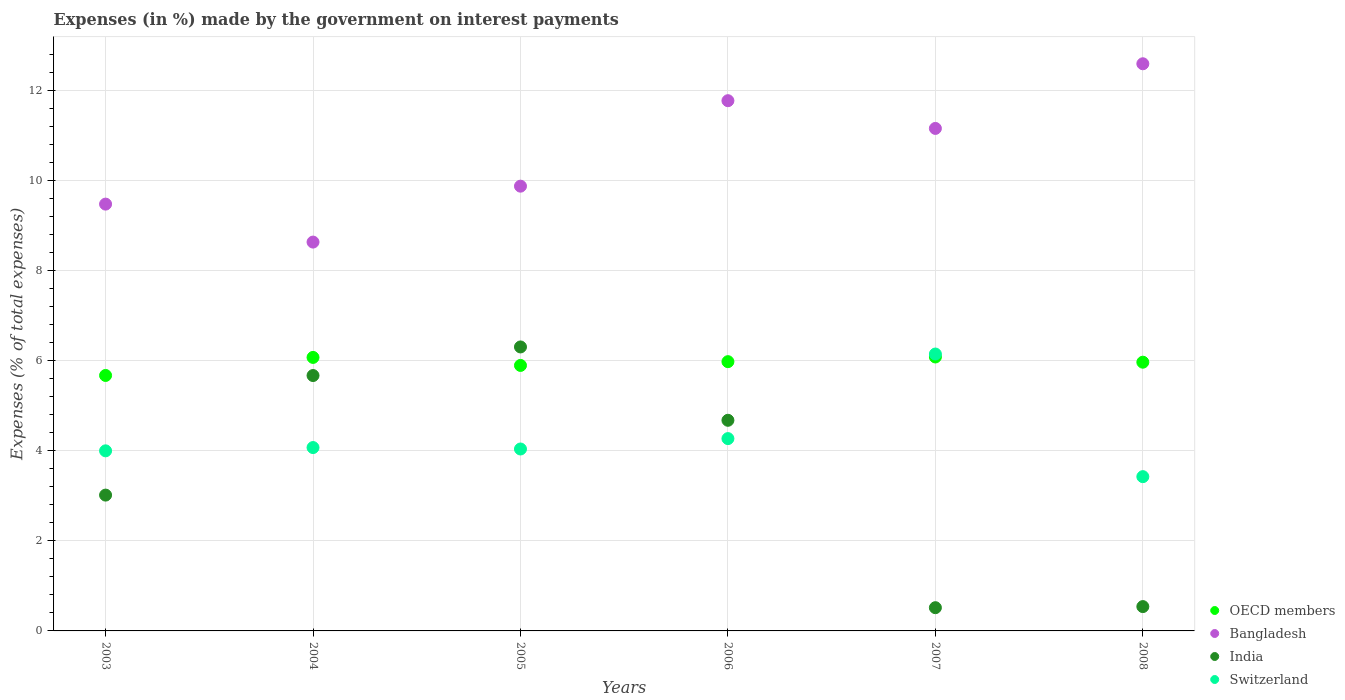How many different coloured dotlines are there?
Make the answer very short. 4. Is the number of dotlines equal to the number of legend labels?
Your answer should be very brief. Yes. What is the percentage of expenses made by the government on interest payments in Bangladesh in 2004?
Ensure brevity in your answer.  8.63. Across all years, what is the maximum percentage of expenses made by the government on interest payments in OECD members?
Give a very brief answer. 6.08. Across all years, what is the minimum percentage of expenses made by the government on interest payments in Bangladesh?
Your response must be concise. 8.63. In which year was the percentage of expenses made by the government on interest payments in OECD members maximum?
Keep it short and to the point. 2007. What is the total percentage of expenses made by the government on interest payments in OECD members in the graph?
Ensure brevity in your answer.  35.66. What is the difference between the percentage of expenses made by the government on interest payments in Bangladesh in 2005 and that in 2007?
Provide a short and direct response. -1.28. What is the difference between the percentage of expenses made by the government on interest payments in India in 2003 and the percentage of expenses made by the government on interest payments in Switzerland in 2008?
Provide a short and direct response. -0.41. What is the average percentage of expenses made by the government on interest payments in Bangladesh per year?
Provide a short and direct response. 10.58. In the year 2006, what is the difference between the percentage of expenses made by the government on interest payments in Switzerland and percentage of expenses made by the government on interest payments in Bangladesh?
Provide a succinct answer. -7.5. What is the ratio of the percentage of expenses made by the government on interest payments in India in 2003 to that in 2005?
Your answer should be compact. 0.48. Is the percentage of expenses made by the government on interest payments in Bangladesh in 2004 less than that in 2006?
Provide a short and direct response. Yes. What is the difference between the highest and the second highest percentage of expenses made by the government on interest payments in OECD members?
Offer a very short reply. 0.01. What is the difference between the highest and the lowest percentage of expenses made by the government on interest payments in Switzerland?
Your answer should be very brief. 2.72. In how many years, is the percentage of expenses made by the government on interest payments in Bangladesh greater than the average percentage of expenses made by the government on interest payments in Bangladesh taken over all years?
Your answer should be very brief. 3. Is the sum of the percentage of expenses made by the government on interest payments in Switzerland in 2007 and 2008 greater than the maximum percentage of expenses made by the government on interest payments in India across all years?
Offer a very short reply. Yes. Is the percentage of expenses made by the government on interest payments in Switzerland strictly greater than the percentage of expenses made by the government on interest payments in India over the years?
Make the answer very short. No. How many dotlines are there?
Your answer should be very brief. 4. How many years are there in the graph?
Provide a succinct answer. 6. What is the difference between two consecutive major ticks on the Y-axis?
Keep it short and to the point. 2. Are the values on the major ticks of Y-axis written in scientific E-notation?
Ensure brevity in your answer.  No. Does the graph contain grids?
Ensure brevity in your answer.  Yes. Where does the legend appear in the graph?
Ensure brevity in your answer.  Bottom right. How many legend labels are there?
Offer a terse response. 4. How are the legend labels stacked?
Give a very brief answer. Vertical. What is the title of the graph?
Give a very brief answer. Expenses (in %) made by the government on interest payments. What is the label or title of the Y-axis?
Give a very brief answer. Expenses (% of total expenses). What is the Expenses (% of total expenses) of OECD members in 2003?
Offer a terse response. 5.67. What is the Expenses (% of total expenses) of Bangladesh in 2003?
Your answer should be very brief. 9.48. What is the Expenses (% of total expenses) of India in 2003?
Make the answer very short. 3.02. What is the Expenses (% of total expenses) of Switzerland in 2003?
Give a very brief answer. 4. What is the Expenses (% of total expenses) of OECD members in 2004?
Provide a short and direct response. 6.07. What is the Expenses (% of total expenses) of Bangladesh in 2004?
Your answer should be very brief. 8.63. What is the Expenses (% of total expenses) in India in 2004?
Your response must be concise. 5.67. What is the Expenses (% of total expenses) of Switzerland in 2004?
Make the answer very short. 4.07. What is the Expenses (% of total expenses) in OECD members in 2005?
Make the answer very short. 5.89. What is the Expenses (% of total expenses) of Bangladesh in 2005?
Keep it short and to the point. 9.87. What is the Expenses (% of total expenses) in India in 2005?
Offer a terse response. 6.3. What is the Expenses (% of total expenses) of Switzerland in 2005?
Give a very brief answer. 4.04. What is the Expenses (% of total expenses) of OECD members in 2006?
Provide a succinct answer. 5.98. What is the Expenses (% of total expenses) in Bangladesh in 2006?
Provide a short and direct response. 11.77. What is the Expenses (% of total expenses) of India in 2006?
Provide a succinct answer. 4.68. What is the Expenses (% of total expenses) of Switzerland in 2006?
Keep it short and to the point. 4.27. What is the Expenses (% of total expenses) of OECD members in 2007?
Make the answer very short. 6.08. What is the Expenses (% of total expenses) in Bangladesh in 2007?
Give a very brief answer. 11.16. What is the Expenses (% of total expenses) in India in 2007?
Offer a very short reply. 0.52. What is the Expenses (% of total expenses) in Switzerland in 2007?
Give a very brief answer. 6.15. What is the Expenses (% of total expenses) in OECD members in 2008?
Keep it short and to the point. 5.97. What is the Expenses (% of total expenses) in Bangladesh in 2008?
Provide a succinct answer. 12.59. What is the Expenses (% of total expenses) in India in 2008?
Your answer should be compact. 0.54. What is the Expenses (% of total expenses) in Switzerland in 2008?
Provide a short and direct response. 3.42. Across all years, what is the maximum Expenses (% of total expenses) of OECD members?
Provide a succinct answer. 6.08. Across all years, what is the maximum Expenses (% of total expenses) in Bangladesh?
Make the answer very short. 12.59. Across all years, what is the maximum Expenses (% of total expenses) in India?
Your answer should be very brief. 6.3. Across all years, what is the maximum Expenses (% of total expenses) of Switzerland?
Your answer should be compact. 6.15. Across all years, what is the minimum Expenses (% of total expenses) of OECD members?
Offer a terse response. 5.67. Across all years, what is the minimum Expenses (% of total expenses) in Bangladesh?
Your answer should be very brief. 8.63. Across all years, what is the minimum Expenses (% of total expenses) in India?
Make the answer very short. 0.52. Across all years, what is the minimum Expenses (% of total expenses) of Switzerland?
Your answer should be compact. 3.42. What is the total Expenses (% of total expenses) in OECD members in the graph?
Make the answer very short. 35.66. What is the total Expenses (% of total expenses) in Bangladesh in the graph?
Give a very brief answer. 63.5. What is the total Expenses (% of total expenses) of India in the graph?
Provide a short and direct response. 20.72. What is the total Expenses (% of total expenses) in Switzerland in the graph?
Give a very brief answer. 25.95. What is the difference between the Expenses (% of total expenses) of OECD members in 2003 and that in 2004?
Your answer should be very brief. -0.4. What is the difference between the Expenses (% of total expenses) in Bangladesh in 2003 and that in 2004?
Provide a succinct answer. 0.84. What is the difference between the Expenses (% of total expenses) of India in 2003 and that in 2004?
Provide a succinct answer. -2.65. What is the difference between the Expenses (% of total expenses) of Switzerland in 2003 and that in 2004?
Offer a terse response. -0.07. What is the difference between the Expenses (% of total expenses) in OECD members in 2003 and that in 2005?
Give a very brief answer. -0.22. What is the difference between the Expenses (% of total expenses) in Bangladesh in 2003 and that in 2005?
Ensure brevity in your answer.  -0.4. What is the difference between the Expenses (% of total expenses) in India in 2003 and that in 2005?
Provide a succinct answer. -3.29. What is the difference between the Expenses (% of total expenses) in Switzerland in 2003 and that in 2005?
Provide a short and direct response. -0.04. What is the difference between the Expenses (% of total expenses) in OECD members in 2003 and that in 2006?
Your response must be concise. -0.31. What is the difference between the Expenses (% of total expenses) of Bangladesh in 2003 and that in 2006?
Your answer should be very brief. -2.3. What is the difference between the Expenses (% of total expenses) of India in 2003 and that in 2006?
Provide a succinct answer. -1.66. What is the difference between the Expenses (% of total expenses) in Switzerland in 2003 and that in 2006?
Your answer should be compact. -0.27. What is the difference between the Expenses (% of total expenses) of OECD members in 2003 and that in 2007?
Provide a succinct answer. -0.41. What is the difference between the Expenses (% of total expenses) in Bangladesh in 2003 and that in 2007?
Ensure brevity in your answer.  -1.68. What is the difference between the Expenses (% of total expenses) of India in 2003 and that in 2007?
Your answer should be very brief. 2.5. What is the difference between the Expenses (% of total expenses) of Switzerland in 2003 and that in 2007?
Offer a terse response. -2.15. What is the difference between the Expenses (% of total expenses) of OECD members in 2003 and that in 2008?
Give a very brief answer. -0.29. What is the difference between the Expenses (% of total expenses) in Bangladesh in 2003 and that in 2008?
Keep it short and to the point. -3.12. What is the difference between the Expenses (% of total expenses) of India in 2003 and that in 2008?
Offer a very short reply. 2.48. What is the difference between the Expenses (% of total expenses) in Switzerland in 2003 and that in 2008?
Provide a short and direct response. 0.57. What is the difference between the Expenses (% of total expenses) in OECD members in 2004 and that in 2005?
Your response must be concise. 0.18. What is the difference between the Expenses (% of total expenses) in Bangladesh in 2004 and that in 2005?
Offer a very short reply. -1.24. What is the difference between the Expenses (% of total expenses) of India in 2004 and that in 2005?
Offer a very short reply. -0.63. What is the difference between the Expenses (% of total expenses) of Switzerland in 2004 and that in 2005?
Give a very brief answer. 0.03. What is the difference between the Expenses (% of total expenses) in OECD members in 2004 and that in 2006?
Keep it short and to the point. 0.09. What is the difference between the Expenses (% of total expenses) in Bangladesh in 2004 and that in 2006?
Keep it short and to the point. -3.14. What is the difference between the Expenses (% of total expenses) of India in 2004 and that in 2006?
Offer a very short reply. 0.99. What is the difference between the Expenses (% of total expenses) of Switzerland in 2004 and that in 2006?
Offer a very short reply. -0.2. What is the difference between the Expenses (% of total expenses) in OECD members in 2004 and that in 2007?
Your answer should be compact. -0.01. What is the difference between the Expenses (% of total expenses) in Bangladesh in 2004 and that in 2007?
Make the answer very short. -2.52. What is the difference between the Expenses (% of total expenses) in India in 2004 and that in 2007?
Ensure brevity in your answer.  5.15. What is the difference between the Expenses (% of total expenses) in Switzerland in 2004 and that in 2007?
Keep it short and to the point. -2.08. What is the difference between the Expenses (% of total expenses) in OECD members in 2004 and that in 2008?
Offer a terse response. 0.11. What is the difference between the Expenses (% of total expenses) in Bangladesh in 2004 and that in 2008?
Keep it short and to the point. -3.96. What is the difference between the Expenses (% of total expenses) in India in 2004 and that in 2008?
Make the answer very short. 5.13. What is the difference between the Expenses (% of total expenses) in Switzerland in 2004 and that in 2008?
Offer a terse response. 0.65. What is the difference between the Expenses (% of total expenses) of OECD members in 2005 and that in 2006?
Offer a terse response. -0.08. What is the difference between the Expenses (% of total expenses) in Bangladesh in 2005 and that in 2006?
Offer a very short reply. -1.9. What is the difference between the Expenses (% of total expenses) of India in 2005 and that in 2006?
Keep it short and to the point. 1.63. What is the difference between the Expenses (% of total expenses) in Switzerland in 2005 and that in 2006?
Provide a succinct answer. -0.23. What is the difference between the Expenses (% of total expenses) of OECD members in 2005 and that in 2007?
Your answer should be very brief. -0.19. What is the difference between the Expenses (% of total expenses) of Bangladesh in 2005 and that in 2007?
Give a very brief answer. -1.28. What is the difference between the Expenses (% of total expenses) of India in 2005 and that in 2007?
Your response must be concise. 5.79. What is the difference between the Expenses (% of total expenses) of Switzerland in 2005 and that in 2007?
Your answer should be very brief. -2.11. What is the difference between the Expenses (% of total expenses) in OECD members in 2005 and that in 2008?
Your answer should be very brief. -0.07. What is the difference between the Expenses (% of total expenses) in Bangladesh in 2005 and that in 2008?
Your answer should be very brief. -2.72. What is the difference between the Expenses (% of total expenses) in India in 2005 and that in 2008?
Make the answer very short. 5.76. What is the difference between the Expenses (% of total expenses) of Switzerland in 2005 and that in 2008?
Give a very brief answer. 0.61. What is the difference between the Expenses (% of total expenses) in OECD members in 2006 and that in 2007?
Provide a short and direct response. -0.1. What is the difference between the Expenses (% of total expenses) in Bangladesh in 2006 and that in 2007?
Provide a short and direct response. 0.62. What is the difference between the Expenses (% of total expenses) in India in 2006 and that in 2007?
Your response must be concise. 4.16. What is the difference between the Expenses (% of total expenses) of Switzerland in 2006 and that in 2007?
Make the answer very short. -1.88. What is the difference between the Expenses (% of total expenses) in OECD members in 2006 and that in 2008?
Your answer should be compact. 0.01. What is the difference between the Expenses (% of total expenses) of Bangladesh in 2006 and that in 2008?
Offer a very short reply. -0.82. What is the difference between the Expenses (% of total expenses) in India in 2006 and that in 2008?
Offer a terse response. 4.14. What is the difference between the Expenses (% of total expenses) in Switzerland in 2006 and that in 2008?
Offer a terse response. 0.84. What is the difference between the Expenses (% of total expenses) of OECD members in 2007 and that in 2008?
Provide a succinct answer. 0.12. What is the difference between the Expenses (% of total expenses) of Bangladesh in 2007 and that in 2008?
Your answer should be very brief. -1.44. What is the difference between the Expenses (% of total expenses) in India in 2007 and that in 2008?
Your answer should be compact. -0.02. What is the difference between the Expenses (% of total expenses) in Switzerland in 2007 and that in 2008?
Offer a terse response. 2.72. What is the difference between the Expenses (% of total expenses) of OECD members in 2003 and the Expenses (% of total expenses) of Bangladesh in 2004?
Provide a succinct answer. -2.96. What is the difference between the Expenses (% of total expenses) of OECD members in 2003 and the Expenses (% of total expenses) of India in 2004?
Your response must be concise. 0. What is the difference between the Expenses (% of total expenses) of OECD members in 2003 and the Expenses (% of total expenses) of Switzerland in 2004?
Provide a short and direct response. 1.6. What is the difference between the Expenses (% of total expenses) in Bangladesh in 2003 and the Expenses (% of total expenses) in India in 2004?
Give a very brief answer. 3.81. What is the difference between the Expenses (% of total expenses) of Bangladesh in 2003 and the Expenses (% of total expenses) of Switzerland in 2004?
Your answer should be compact. 5.4. What is the difference between the Expenses (% of total expenses) in India in 2003 and the Expenses (% of total expenses) in Switzerland in 2004?
Provide a succinct answer. -1.06. What is the difference between the Expenses (% of total expenses) of OECD members in 2003 and the Expenses (% of total expenses) of Bangladesh in 2005?
Your response must be concise. -4.2. What is the difference between the Expenses (% of total expenses) of OECD members in 2003 and the Expenses (% of total expenses) of India in 2005?
Make the answer very short. -0.63. What is the difference between the Expenses (% of total expenses) in OECD members in 2003 and the Expenses (% of total expenses) in Switzerland in 2005?
Provide a succinct answer. 1.63. What is the difference between the Expenses (% of total expenses) in Bangladesh in 2003 and the Expenses (% of total expenses) in India in 2005?
Provide a short and direct response. 3.17. What is the difference between the Expenses (% of total expenses) of Bangladesh in 2003 and the Expenses (% of total expenses) of Switzerland in 2005?
Offer a very short reply. 5.44. What is the difference between the Expenses (% of total expenses) in India in 2003 and the Expenses (% of total expenses) in Switzerland in 2005?
Offer a terse response. -1.02. What is the difference between the Expenses (% of total expenses) in OECD members in 2003 and the Expenses (% of total expenses) in Bangladesh in 2006?
Provide a succinct answer. -6.1. What is the difference between the Expenses (% of total expenses) of OECD members in 2003 and the Expenses (% of total expenses) of Switzerland in 2006?
Your answer should be very brief. 1.4. What is the difference between the Expenses (% of total expenses) in Bangladesh in 2003 and the Expenses (% of total expenses) in India in 2006?
Offer a terse response. 4.8. What is the difference between the Expenses (% of total expenses) in Bangladesh in 2003 and the Expenses (% of total expenses) in Switzerland in 2006?
Provide a short and direct response. 5.21. What is the difference between the Expenses (% of total expenses) of India in 2003 and the Expenses (% of total expenses) of Switzerland in 2006?
Provide a short and direct response. -1.25. What is the difference between the Expenses (% of total expenses) of OECD members in 2003 and the Expenses (% of total expenses) of Bangladesh in 2007?
Offer a very short reply. -5.48. What is the difference between the Expenses (% of total expenses) in OECD members in 2003 and the Expenses (% of total expenses) in India in 2007?
Your answer should be compact. 5.16. What is the difference between the Expenses (% of total expenses) in OECD members in 2003 and the Expenses (% of total expenses) in Switzerland in 2007?
Your answer should be very brief. -0.48. What is the difference between the Expenses (% of total expenses) in Bangladesh in 2003 and the Expenses (% of total expenses) in India in 2007?
Your answer should be very brief. 8.96. What is the difference between the Expenses (% of total expenses) of Bangladesh in 2003 and the Expenses (% of total expenses) of Switzerland in 2007?
Keep it short and to the point. 3.33. What is the difference between the Expenses (% of total expenses) of India in 2003 and the Expenses (% of total expenses) of Switzerland in 2007?
Your answer should be compact. -3.13. What is the difference between the Expenses (% of total expenses) in OECD members in 2003 and the Expenses (% of total expenses) in Bangladesh in 2008?
Your answer should be compact. -6.92. What is the difference between the Expenses (% of total expenses) of OECD members in 2003 and the Expenses (% of total expenses) of India in 2008?
Offer a very short reply. 5.13. What is the difference between the Expenses (% of total expenses) in OECD members in 2003 and the Expenses (% of total expenses) in Switzerland in 2008?
Give a very brief answer. 2.25. What is the difference between the Expenses (% of total expenses) in Bangladesh in 2003 and the Expenses (% of total expenses) in India in 2008?
Offer a very short reply. 8.94. What is the difference between the Expenses (% of total expenses) of Bangladesh in 2003 and the Expenses (% of total expenses) of Switzerland in 2008?
Your answer should be compact. 6.05. What is the difference between the Expenses (% of total expenses) in India in 2003 and the Expenses (% of total expenses) in Switzerland in 2008?
Give a very brief answer. -0.41. What is the difference between the Expenses (% of total expenses) of OECD members in 2004 and the Expenses (% of total expenses) of Bangladesh in 2005?
Your answer should be compact. -3.8. What is the difference between the Expenses (% of total expenses) in OECD members in 2004 and the Expenses (% of total expenses) in India in 2005?
Your answer should be compact. -0.23. What is the difference between the Expenses (% of total expenses) in OECD members in 2004 and the Expenses (% of total expenses) in Switzerland in 2005?
Offer a very short reply. 2.03. What is the difference between the Expenses (% of total expenses) of Bangladesh in 2004 and the Expenses (% of total expenses) of India in 2005?
Your answer should be very brief. 2.33. What is the difference between the Expenses (% of total expenses) of Bangladesh in 2004 and the Expenses (% of total expenses) of Switzerland in 2005?
Your answer should be compact. 4.59. What is the difference between the Expenses (% of total expenses) of India in 2004 and the Expenses (% of total expenses) of Switzerland in 2005?
Your answer should be very brief. 1.63. What is the difference between the Expenses (% of total expenses) in OECD members in 2004 and the Expenses (% of total expenses) in Bangladesh in 2006?
Keep it short and to the point. -5.7. What is the difference between the Expenses (% of total expenses) of OECD members in 2004 and the Expenses (% of total expenses) of India in 2006?
Give a very brief answer. 1.4. What is the difference between the Expenses (% of total expenses) in OECD members in 2004 and the Expenses (% of total expenses) in Switzerland in 2006?
Make the answer very short. 1.8. What is the difference between the Expenses (% of total expenses) in Bangladesh in 2004 and the Expenses (% of total expenses) in India in 2006?
Keep it short and to the point. 3.96. What is the difference between the Expenses (% of total expenses) in Bangladesh in 2004 and the Expenses (% of total expenses) in Switzerland in 2006?
Keep it short and to the point. 4.36. What is the difference between the Expenses (% of total expenses) in India in 2004 and the Expenses (% of total expenses) in Switzerland in 2006?
Offer a very short reply. 1.4. What is the difference between the Expenses (% of total expenses) in OECD members in 2004 and the Expenses (% of total expenses) in Bangladesh in 2007?
Offer a terse response. -5.08. What is the difference between the Expenses (% of total expenses) in OECD members in 2004 and the Expenses (% of total expenses) in India in 2007?
Offer a very short reply. 5.56. What is the difference between the Expenses (% of total expenses) of OECD members in 2004 and the Expenses (% of total expenses) of Switzerland in 2007?
Offer a terse response. -0.08. What is the difference between the Expenses (% of total expenses) of Bangladesh in 2004 and the Expenses (% of total expenses) of India in 2007?
Give a very brief answer. 8.12. What is the difference between the Expenses (% of total expenses) in Bangladesh in 2004 and the Expenses (% of total expenses) in Switzerland in 2007?
Offer a very short reply. 2.49. What is the difference between the Expenses (% of total expenses) of India in 2004 and the Expenses (% of total expenses) of Switzerland in 2007?
Provide a short and direct response. -0.48. What is the difference between the Expenses (% of total expenses) in OECD members in 2004 and the Expenses (% of total expenses) in Bangladesh in 2008?
Provide a short and direct response. -6.52. What is the difference between the Expenses (% of total expenses) of OECD members in 2004 and the Expenses (% of total expenses) of India in 2008?
Your answer should be very brief. 5.53. What is the difference between the Expenses (% of total expenses) of OECD members in 2004 and the Expenses (% of total expenses) of Switzerland in 2008?
Your response must be concise. 2.65. What is the difference between the Expenses (% of total expenses) in Bangladesh in 2004 and the Expenses (% of total expenses) in India in 2008?
Offer a very short reply. 8.09. What is the difference between the Expenses (% of total expenses) in Bangladesh in 2004 and the Expenses (% of total expenses) in Switzerland in 2008?
Your answer should be compact. 5.21. What is the difference between the Expenses (% of total expenses) in India in 2004 and the Expenses (% of total expenses) in Switzerland in 2008?
Keep it short and to the point. 2.24. What is the difference between the Expenses (% of total expenses) of OECD members in 2005 and the Expenses (% of total expenses) of Bangladesh in 2006?
Keep it short and to the point. -5.88. What is the difference between the Expenses (% of total expenses) in OECD members in 2005 and the Expenses (% of total expenses) in India in 2006?
Your response must be concise. 1.22. What is the difference between the Expenses (% of total expenses) in OECD members in 2005 and the Expenses (% of total expenses) in Switzerland in 2006?
Keep it short and to the point. 1.62. What is the difference between the Expenses (% of total expenses) of Bangladesh in 2005 and the Expenses (% of total expenses) of India in 2006?
Keep it short and to the point. 5.2. What is the difference between the Expenses (% of total expenses) in Bangladesh in 2005 and the Expenses (% of total expenses) in Switzerland in 2006?
Offer a very short reply. 5.6. What is the difference between the Expenses (% of total expenses) in India in 2005 and the Expenses (% of total expenses) in Switzerland in 2006?
Your answer should be compact. 2.03. What is the difference between the Expenses (% of total expenses) in OECD members in 2005 and the Expenses (% of total expenses) in Bangladesh in 2007?
Your answer should be compact. -5.26. What is the difference between the Expenses (% of total expenses) in OECD members in 2005 and the Expenses (% of total expenses) in India in 2007?
Your answer should be compact. 5.38. What is the difference between the Expenses (% of total expenses) in OECD members in 2005 and the Expenses (% of total expenses) in Switzerland in 2007?
Ensure brevity in your answer.  -0.25. What is the difference between the Expenses (% of total expenses) of Bangladesh in 2005 and the Expenses (% of total expenses) of India in 2007?
Your answer should be very brief. 9.36. What is the difference between the Expenses (% of total expenses) in Bangladesh in 2005 and the Expenses (% of total expenses) in Switzerland in 2007?
Provide a short and direct response. 3.73. What is the difference between the Expenses (% of total expenses) of India in 2005 and the Expenses (% of total expenses) of Switzerland in 2007?
Provide a succinct answer. 0.16. What is the difference between the Expenses (% of total expenses) of OECD members in 2005 and the Expenses (% of total expenses) of Bangladesh in 2008?
Your response must be concise. -6.7. What is the difference between the Expenses (% of total expenses) of OECD members in 2005 and the Expenses (% of total expenses) of India in 2008?
Give a very brief answer. 5.35. What is the difference between the Expenses (% of total expenses) of OECD members in 2005 and the Expenses (% of total expenses) of Switzerland in 2008?
Offer a terse response. 2.47. What is the difference between the Expenses (% of total expenses) of Bangladesh in 2005 and the Expenses (% of total expenses) of India in 2008?
Keep it short and to the point. 9.33. What is the difference between the Expenses (% of total expenses) in Bangladesh in 2005 and the Expenses (% of total expenses) in Switzerland in 2008?
Give a very brief answer. 6.45. What is the difference between the Expenses (% of total expenses) of India in 2005 and the Expenses (% of total expenses) of Switzerland in 2008?
Your response must be concise. 2.88. What is the difference between the Expenses (% of total expenses) of OECD members in 2006 and the Expenses (% of total expenses) of Bangladesh in 2007?
Provide a succinct answer. -5.18. What is the difference between the Expenses (% of total expenses) of OECD members in 2006 and the Expenses (% of total expenses) of India in 2007?
Keep it short and to the point. 5.46. What is the difference between the Expenses (% of total expenses) in OECD members in 2006 and the Expenses (% of total expenses) in Switzerland in 2007?
Offer a terse response. -0.17. What is the difference between the Expenses (% of total expenses) in Bangladesh in 2006 and the Expenses (% of total expenses) in India in 2007?
Provide a succinct answer. 11.26. What is the difference between the Expenses (% of total expenses) of Bangladesh in 2006 and the Expenses (% of total expenses) of Switzerland in 2007?
Your response must be concise. 5.62. What is the difference between the Expenses (% of total expenses) in India in 2006 and the Expenses (% of total expenses) in Switzerland in 2007?
Make the answer very short. -1.47. What is the difference between the Expenses (% of total expenses) of OECD members in 2006 and the Expenses (% of total expenses) of Bangladesh in 2008?
Your answer should be very brief. -6.61. What is the difference between the Expenses (% of total expenses) of OECD members in 2006 and the Expenses (% of total expenses) of India in 2008?
Ensure brevity in your answer.  5.44. What is the difference between the Expenses (% of total expenses) in OECD members in 2006 and the Expenses (% of total expenses) in Switzerland in 2008?
Provide a short and direct response. 2.55. What is the difference between the Expenses (% of total expenses) in Bangladesh in 2006 and the Expenses (% of total expenses) in India in 2008?
Your response must be concise. 11.23. What is the difference between the Expenses (% of total expenses) in Bangladesh in 2006 and the Expenses (% of total expenses) in Switzerland in 2008?
Provide a succinct answer. 8.35. What is the difference between the Expenses (% of total expenses) in India in 2006 and the Expenses (% of total expenses) in Switzerland in 2008?
Provide a short and direct response. 1.25. What is the difference between the Expenses (% of total expenses) of OECD members in 2007 and the Expenses (% of total expenses) of Bangladesh in 2008?
Give a very brief answer. -6.51. What is the difference between the Expenses (% of total expenses) of OECD members in 2007 and the Expenses (% of total expenses) of India in 2008?
Ensure brevity in your answer.  5.54. What is the difference between the Expenses (% of total expenses) in OECD members in 2007 and the Expenses (% of total expenses) in Switzerland in 2008?
Offer a terse response. 2.66. What is the difference between the Expenses (% of total expenses) of Bangladesh in 2007 and the Expenses (% of total expenses) of India in 2008?
Keep it short and to the point. 10.62. What is the difference between the Expenses (% of total expenses) in Bangladesh in 2007 and the Expenses (% of total expenses) in Switzerland in 2008?
Give a very brief answer. 7.73. What is the difference between the Expenses (% of total expenses) in India in 2007 and the Expenses (% of total expenses) in Switzerland in 2008?
Give a very brief answer. -2.91. What is the average Expenses (% of total expenses) in OECD members per year?
Offer a very short reply. 5.94. What is the average Expenses (% of total expenses) of Bangladesh per year?
Your response must be concise. 10.58. What is the average Expenses (% of total expenses) in India per year?
Offer a very short reply. 3.45. What is the average Expenses (% of total expenses) of Switzerland per year?
Give a very brief answer. 4.32. In the year 2003, what is the difference between the Expenses (% of total expenses) of OECD members and Expenses (% of total expenses) of Bangladesh?
Ensure brevity in your answer.  -3.8. In the year 2003, what is the difference between the Expenses (% of total expenses) in OECD members and Expenses (% of total expenses) in India?
Your answer should be very brief. 2.66. In the year 2003, what is the difference between the Expenses (% of total expenses) of OECD members and Expenses (% of total expenses) of Switzerland?
Your answer should be very brief. 1.67. In the year 2003, what is the difference between the Expenses (% of total expenses) of Bangladesh and Expenses (% of total expenses) of India?
Keep it short and to the point. 6.46. In the year 2003, what is the difference between the Expenses (% of total expenses) of Bangladesh and Expenses (% of total expenses) of Switzerland?
Provide a succinct answer. 5.48. In the year 2003, what is the difference between the Expenses (% of total expenses) in India and Expenses (% of total expenses) in Switzerland?
Your response must be concise. -0.98. In the year 2004, what is the difference between the Expenses (% of total expenses) of OECD members and Expenses (% of total expenses) of Bangladesh?
Make the answer very short. -2.56. In the year 2004, what is the difference between the Expenses (% of total expenses) in OECD members and Expenses (% of total expenses) in India?
Make the answer very short. 0.4. In the year 2004, what is the difference between the Expenses (% of total expenses) of OECD members and Expenses (% of total expenses) of Switzerland?
Offer a terse response. 2. In the year 2004, what is the difference between the Expenses (% of total expenses) in Bangladesh and Expenses (% of total expenses) in India?
Your answer should be very brief. 2.96. In the year 2004, what is the difference between the Expenses (% of total expenses) of Bangladesh and Expenses (% of total expenses) of Switzerland?
Offer a terse response. 4.56. In the year 2004, what is the difference between the Expenses (% of total expenses) of India and Expenses (% of total expenses) of Switzerland?
Provide a succinct answer. 1.6. In the year 2005, what is the difference between the Expenses (% of total expenses) of OECD members and Expenses (% of total expenses) of Bangladesh?
Provide a short and direct response. -3.98. In the year 2005, what is the difference between the Expenses (% of total expenses) in OECD members and Expenses (% of total expenses) in India?
Provide a succinct answer. -0.41. In the year 2005, what is the difference between the Expenses (% of total expenses) in OECD members and Expenses (% of total expenses) in Switzerland?
Provide a succinct answer. 1.86. In the year 2005, what is the difference between the Expenses (% of total expenses) of Bangladesh and Expenses (% of total expenses) of India?
Keep it short and to the point. 3.57. In the year 2005, what is the difference between the Expenses (% of total expenses) in Bangladesh and Expenses (% of total expenses) in Switzerland?
Your response must be concise. 5.83. In the year 2005, what is the difference between the Expenses (% of total expenses) in India and Expenses (% of total expenses) in Switzerland?
Make the answer very short. 2.27. In the year 2006, what is the difference between the Expenses (% of total expenses) in OECD members and Expenses (% of total expenses) in Bangladesh?
Offer a terse response. -5.79. In the year 2006, what is the difference between the Expenses (% of total expenses) of OECD members and Expenses (% of total expenses) of India?
Your response must be concise. 1.3. In the year 2006, what is the difference between the Expenses (% of total expenses) of OECD members and Expenses (% of total expenses) of Switzerland?
Offer a terse response. 1.71. In the year 2006, what is the difference between the Expenses (% of total expenses) of Bangladesh and Expenses (% of total expenses) of India?
Your response must be concise. 7.1. In the year 2006, what is the difference between the Expenses (% of total expenses) in Bangladesh and Expenses (% of total expenses) in Switzerland?
Ensure brevity in your answer.  7.5. In the year 2006, what is the difference between the Expenses (% of total expenses) in India and Expenses (% of total expenses) in Switzerland?
Offer a terse response. 0.41. In the year 2007, what is the difference between the Expenses (% of total expenses) in OECD members and Expenses (% of total expenses) in Bangladesh?
Provide a short and direct response. -5.07. In the year 2007, what is the difference between the Expenses (% of total expenses) of OECD members and Expenses (% of total expenses) of India?
Keep it short and to the point. 5.57. In the year 2007, what is the difference between the Expenses (% of total expenses) of OECD members and Expenses (% of total expenses) of Switzerland?
Provide a succinct answer. -0.07. In the year 2007, what is the difference between the Expenses (% of total expenses) in Bangladesh and Expenses (% of total expenses) in India?
Give a very brief answer. 10.64. In the year 2007, what is the difference between the Expenses (% of total expenses) of Bangladesh and Expenses (% of total expenses) of Switzerland?
Keep it short and to the point. 5.01. In the year 2007, what is the difference between the Expenses (% of total expenses) in India and Expenses (% of total expenses) in Switzerland?
Keep it short and to the point. -5.63. In the year 2008, what is the difference between the Expenses (% of total expenses) in OECD members and Expenses (% of total expenses) in Bangladesh?
Keep it short and to the point. -6.63. In the year 2008, what is the difference between the Expenses (% of total expenses) in OECD members and Expenses (% of total expenses) in India?
Your answer should be very brief. 5.43. In the year 2008, what is the difference between the Expenses (% of total expenses) of OECD members and Expenses (% of total expenses) of Switzerland?
Give a very brief answer. 2.54. In the year 2008, what is the difference between the Expenses (% of total expenses) of Bangladesh and Expenses (% of total expenses) of India?
Provide a short and direct response. 12.05. In the year 2008, what is the difference between the Expenses (% of total expenses) in Bangladesh and Expenses (% of total expenses) in Switzerland?
Your answer should be compact. 9.17. In the year 2008, what is the difference between the Expenses (% of total expenses) of India and Expenses (% of total expenses) of Switzerland?
Your answer should be very brief. -2.88. What is the ratio of the Expenses (% of total expenses) in OECD members in 2003 to that in 2004?
Keep it short and to the point. 0.93. What is the ratio of the Expenses (% of total expenses) in Bangladesh in 2003 to that in 2004?
Provide a short and direct response. 1.1. What is the ratio of the Expenses (% of total expenses) of India in 2003 to that in 2004?
Keep it short and to the point. 0.53. What is the ratio of the Expenses (% of total expenses) in Switzerland in 2003 to that in 2004?
Make the answer very short. 0.98. What is the ratio of the Expenses (% of total expenses) in OECD members in 2003 to that in 2005?
Provide a short and direct response. 0.96. What is the ratio of the Expenses (% of total expenses) of Bangladesh in 2003 to that in 2005?
Ensure brevity in your answer.  0.96. What is the ratio of the Expenses (% of total expenses) of India in 2003 to that in 2005?
Provide a succinct answer. 0.48. What is the ratio of the Expenses (% of total expenses) in OECD members in 2003 to that in 2006?
Offer a very short reply. 0.95. What is the ratio of the Expenses (% of total expenses) in Bangladesh in 2003 to that in 2006?
Your answer should be very brief. 0.81. What is the ratio of the Expenses (% of total expenses) of India in 2003 to that in 2006?
Your answer should be very brief. 0.64. What is the ratio of the Expenses (% of total expenses) in Switzerland in 2003 to that in 2006?
Keep it short and to the point. 0.94. What is the ratio of the Expenses (% of total expenses) of OECD members in 2003 to that in 2007?
Your response must be concise. 0.93. What is the ratio of the Expenses (% of total expenses) in Bangladesh in 2003 to that in 2007?
Give a very brief answer. 0.85. What is the ratio of the Expenses (% of total expenses) of India in 2003 to that in 2007?
Offer a terse response. 5.85. What is the ratio of the Expenses (% of total expenses) in Switzerland in 2003 to that in 2007?
Offer a terse response. 0.65. What is the ratio of the Expenses (% of total expenses) of OECD members in 2003 to that in 2008?
Provide a short and direct response. 0.95. What is the ratio of the Expenses (% of total expenses) of Bangladesh in 2003 to that in 2008?
Your answer should be very brief. 0.75. What is the ratio of the Expenses (% of total expenses) of India in 2003 to that in 2008?
Provide a succinct answer. 5.58. What is the ratio of the Expenses (% of total expenses) in Switzerland in 2003 to that in 2008?
Your answer should be compact. 1.17. What is the ratio of the Expenses (% of total expenses) of OECD members in 2004 to that in 2005?
Offer a very short reply. 1.03. What is the ratio of the Expenses (% of total expenses) of Bangladesh in 2004 to that in 2005?
Provide a succinct answer. 0.87. What is the ratio of the Expenses (% of total expenses) in India in 2004 to that in 2005?
Give a very brief answer. 0.9. What is the ratio of the Expenses (% of total expenses) in Switzerland in 2004 to that in 2005?
Ensure brevity in your answer.  1.01. What is the ratio of the Expenses (% of total expenses) of OECD members in 2004 to that in 2006?
Provide a succinct answer. 1.02. What is the ratio of the Expenses (% of total expenses) in Bangladesh in 2004 to that in 2006?
Offer a very short reply. 0.73. What is the ratio of the Expenses (% of total expenses) of India in 2004 to that in 2006?
Ensure brevity in your answer.  1.21. What is the ratio of the Expenses (% of total expenses) of Switzerland in 2004 to that in 2006?
Offer a very short reply. 0.95. What is the ratio of the Expenses (% of total expenses) of Bangladesh in 2004 to that in 2007?
Your answer should be compact. 0.77. What is the ratio of the Expenses (% of total expenses) in India in 2004 to that in 2007?
Offer a very short reply. 10.99. What is the ratio of the Expenses (% of total expenses) in Switzerland in 2004 to that in 2007?
Keep it short and to the point. 0.66. What is the ratio of the Expenses (% of total expenses) in OECD members in 2004 to that in 2008?
Your answer should be compact. 1.02. What is the ratio of the Expenses (% of total expenses) in Bangladesh in 2004 to that in 2008?
Ensure brevity in your answer.  0.69. What is the ratio of the Expenses (% of total expenses) of India in 2004 to that in 2008?
Your answer should be very brief. 10.5. What is the ratio of the Expenses (% of total expenses) in Switzerland in 2004 to that in 2008?
Provide a succinct answer. 1.19. What is the ratio of the Expenses (% of total expenses) in OECD members in 2005 to that in 2006?
Your answer should be compact. 0.99. What is the ratio of the Expenses (% of total expenses) in Bangladesh in 2005 to that in 2006?
Your answer should be compact. 0.84. What is the ratio of the Expenses (% of total expenses) in India in 2005 to that in 2006?
Provide a succinct answer. 1.35. What is the ratio of the Expenses (% of total expenses) in Switzerland in 2005 to that in 2006?
Offer a terse response. 0.95. What is the ratio of the Expenses (% of total expenses) of OECD members in 2005 to that in 2007?
Your response must be concise. 0.97. What is the ratio of the Expenses (% of total expenses) of Bangladesh in 2005 to that in 2007?
Offer a terse response. 0.89. What is the ratio of the Expenses (% of total expenses) in India in 2005 to that in 2007?
Give a very brief answer. 12.22. What is the ratio of the Expenses (% of total expenses) of Switzerland in 2005 to that in 2007?
Make the answer very short. 0.66. What is the ratio of the Expenses (% of total expenses) of OECD members in 2005 to that in 2008?
Make the answer very short. 0.99. What is the ratio of the Expenses (% of total expenses) in Bangladesh in 2005 to that in 2008?
Provide a succinct answer. 0.78. What is the ratio of the Expenses (% of total expenses) in India in 2005 to that in 2008?
Provide a succinct answer. 11.67. What is the ratio of the Expenses (% of total expenses) of Switzerland in 2005 to that in 2008?
Keep it short and to the point. 1.18. What is the ratio of the Expenses (% of total expenses) in OECD members in 2006 to that in 2007?
Give a very brief answer. 0.98. What is the ratio of the Expenses (% of total expenses) of Bangladesh in 2006 to that in 2007?
Ensure brevity in your answer.  1.06. What is the ratio of the Expenses (% of total expenses) of India in 2006 to that in 2007?
Give a very brief answer. 9.07. What is the ratio of the Expenses (% of total expenses) in Switzerland in 2006 to that in 2007?
Provide a succinct answer. 0.69. What is the ratio of the Expenses (% of total expenses) in Bangladesh in 2006 to that in 2008?
Your answer should be very brief. 0.93. What is the ratio of the Expenses (% of total expenses) in India in 2006 to that in 2008?
Keep it short and to the point. 8.66. What is the ratio of the Expenses (% of total expenses) of Switzerland in 2006 to that in 2008?
Your answer should be compact. 1.25. What is the ratio of the Expenses (% of total expenses) in OECD members in 2007 to that in 2008?
Provide a short and direct response. 1.02. What is the ratio of the Expenses (% of total expenses) of Bangladesh in 2007 to that in 2008?
Provide a short and direct response. 0.89. What is the ratio of the Expenses (% of total expenses) in India in 2007 to that in 2008?
Offer a very short reply. 0.95. What is the ratio of the Expenses (% of total expenses) in Switzerland in 2007 to that in 2008?
Give a very brief answer. 1.79. What is the difference between the highest and the second highest Expenses (% of total expenses) in OECD members?
Make the answer very short. 0.01. What is the difference between the highest and the second highest Expenses (% of total expenses) in Bangladesh?
Offer a terse response. 0.82. What is the difference between the highest and the second highest Expenses (% of total expenses) of India?
Your response must be concise. 0.63. What is the difference between the highest and the second highest Expenses (% of total expenses) of Switzerland?
Keep it short and to the point. 1.88. What is the difference between the highest and the lowest Expenses (% of total expenses) of OECD members?
Ensure brevity in your answer.  0.41. What is the difference between the highest and the lowest Expenses (% of total expenses) in Bangladesh?
Provide a succinct answer. 3.96. What is the difference between the highest and the lowest Expenses (% of total expenses) in India?
Keep it short and to the point. 5.79. What is the difference between the highest and the lowest Expenses (% of total expenses) of Switzerland?
Provide a succinct answer. 2.72. 